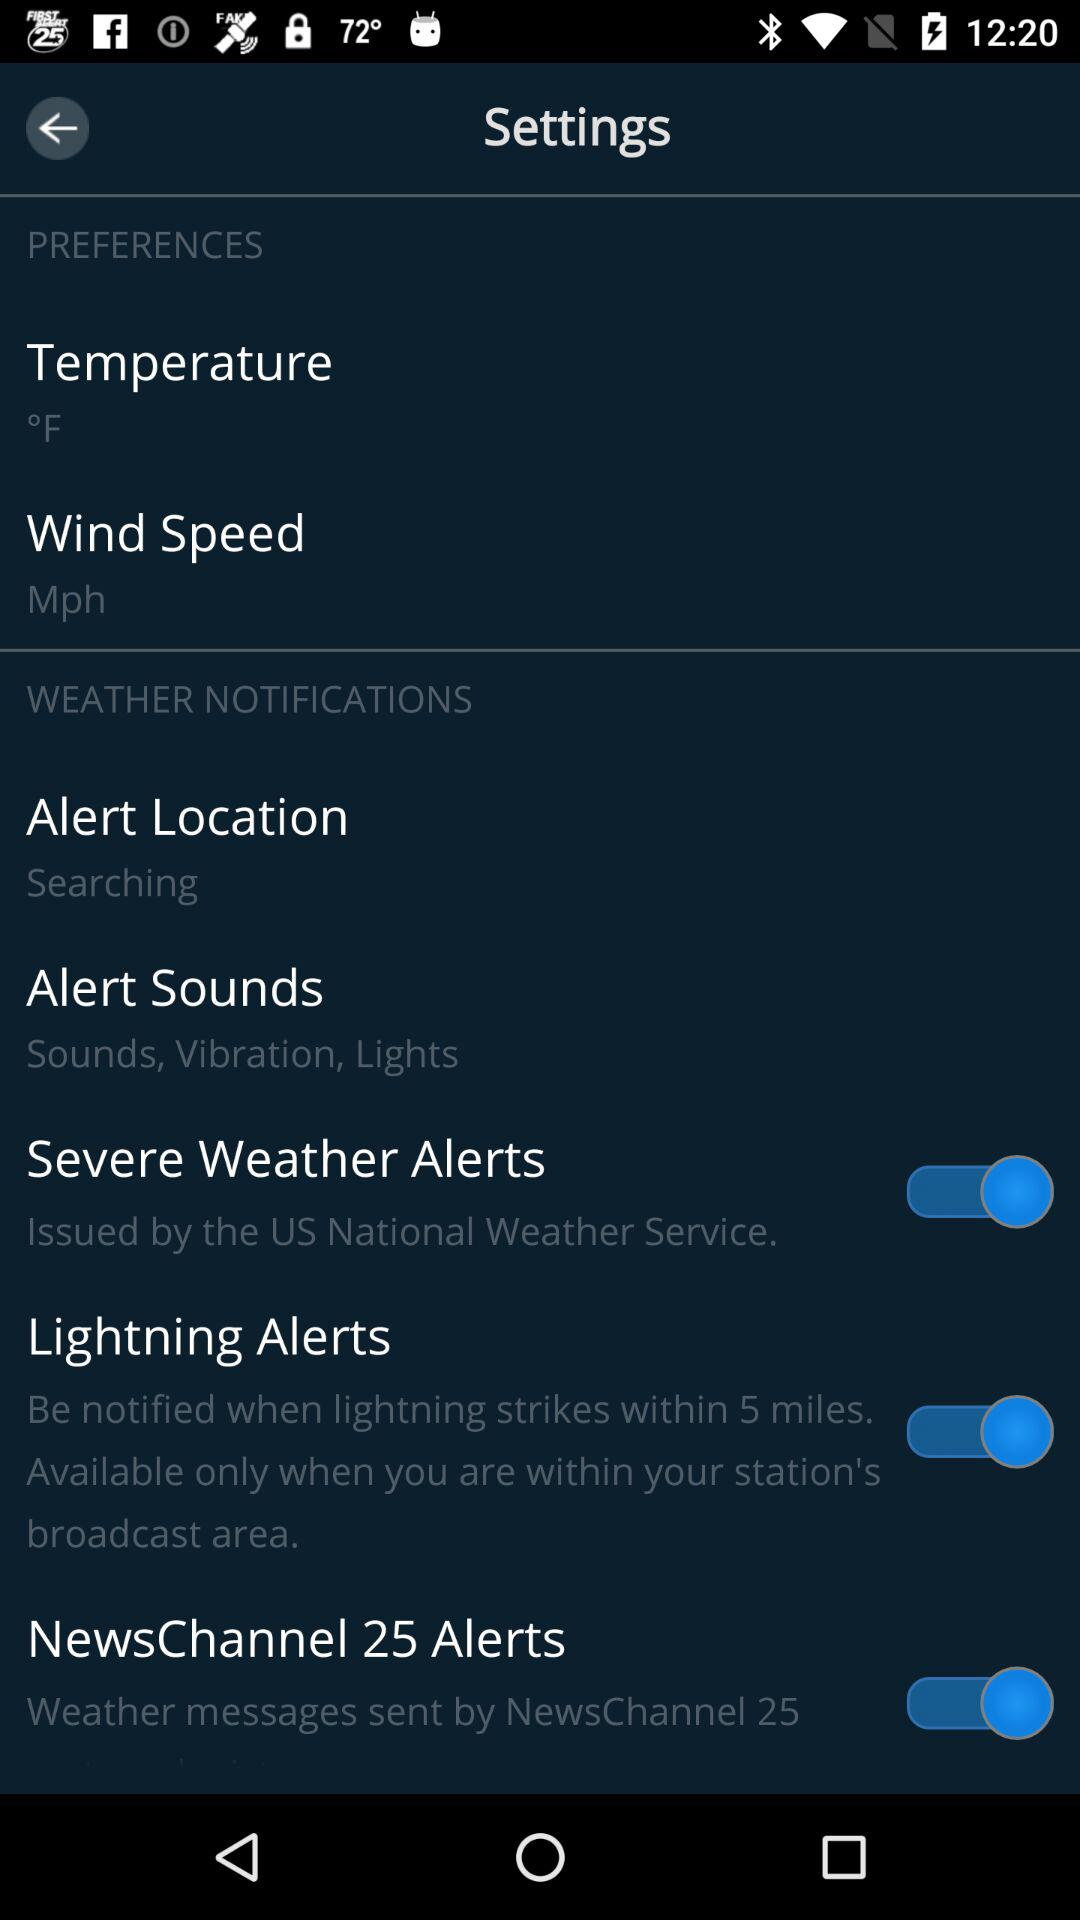What's the measurement unit of wind speed? The measurement unit is mph. 